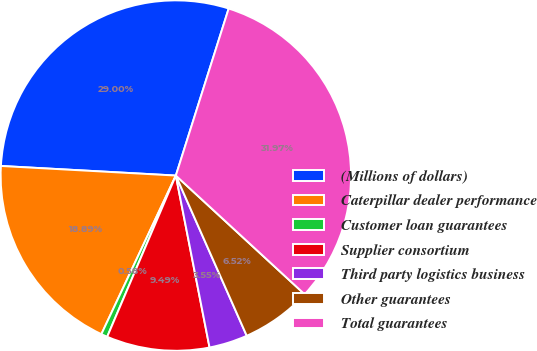Convert chart to OTSL. <chart><loc_0><loc_0><loc_500><loc_500><pie_chart><fcel>(Millions of dollars)<fcel>Caterpillar dealer performance<fcel>Customer loan guarantees<fcel>Supplier consortium<fcel>Third party logistics business<fcel>Other guarantees<fcel>Total guarantees<nl><fcel>29.01%<fcel>18.89%<fcel>0.58%<fcel>9.49%<fcel>3.55%<fcel>6.52%<fcel>31.98%<nl></chart> 